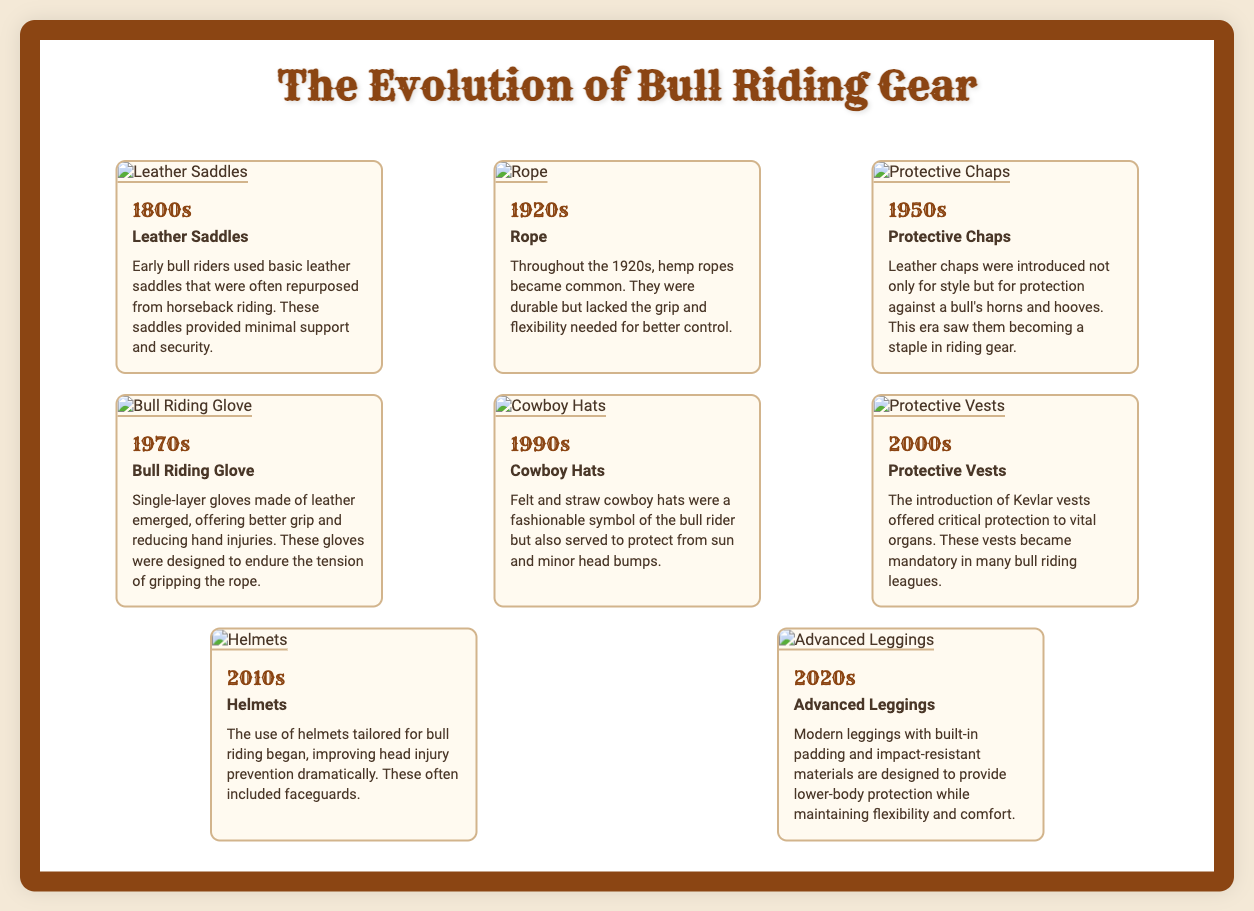what gear item was used in the 1800s? The document mentions leather saddles as the gear item used by bull riders in the 1800s.
Answer: Leather Saddles what decade saw the introduction of protective vests? The introduction of protective vests occurred in the 2000s.
Answer: 2000s which gear item was common in the 1920s? Hemp ropes became common during the 1920s.
Answer: Rope how did bull riding gloves change in the 1970s? The gloves were made of single-layer leather, which improved grip and reduced hand injuries.
Answer: Better grip which item became mandatory in many bull riding leagues? The document states that Kevlar vests became mandatory in many bull riding leagues.
Answer: Protective Vests what type of material is found in modern leggings? Advanced leggings are designed with impact-resistant materials for protection.
Answer: Impact-resistant materials in which decade did helmets become popular for bull riding? Helmets tailored for bull riding gained popularity in the 2010s.
Answer: 2010s what does the gear from the 1990s symbolize? Cowboy hats from the 1990s symbolize both fashion and protection from elements.
Answer: Fashion symbol which gear item saw a major focus on safety in the 2000s? The introduction of protective vests marked a significant focus on safety in the 2000s.
Answer: Protective Vests 